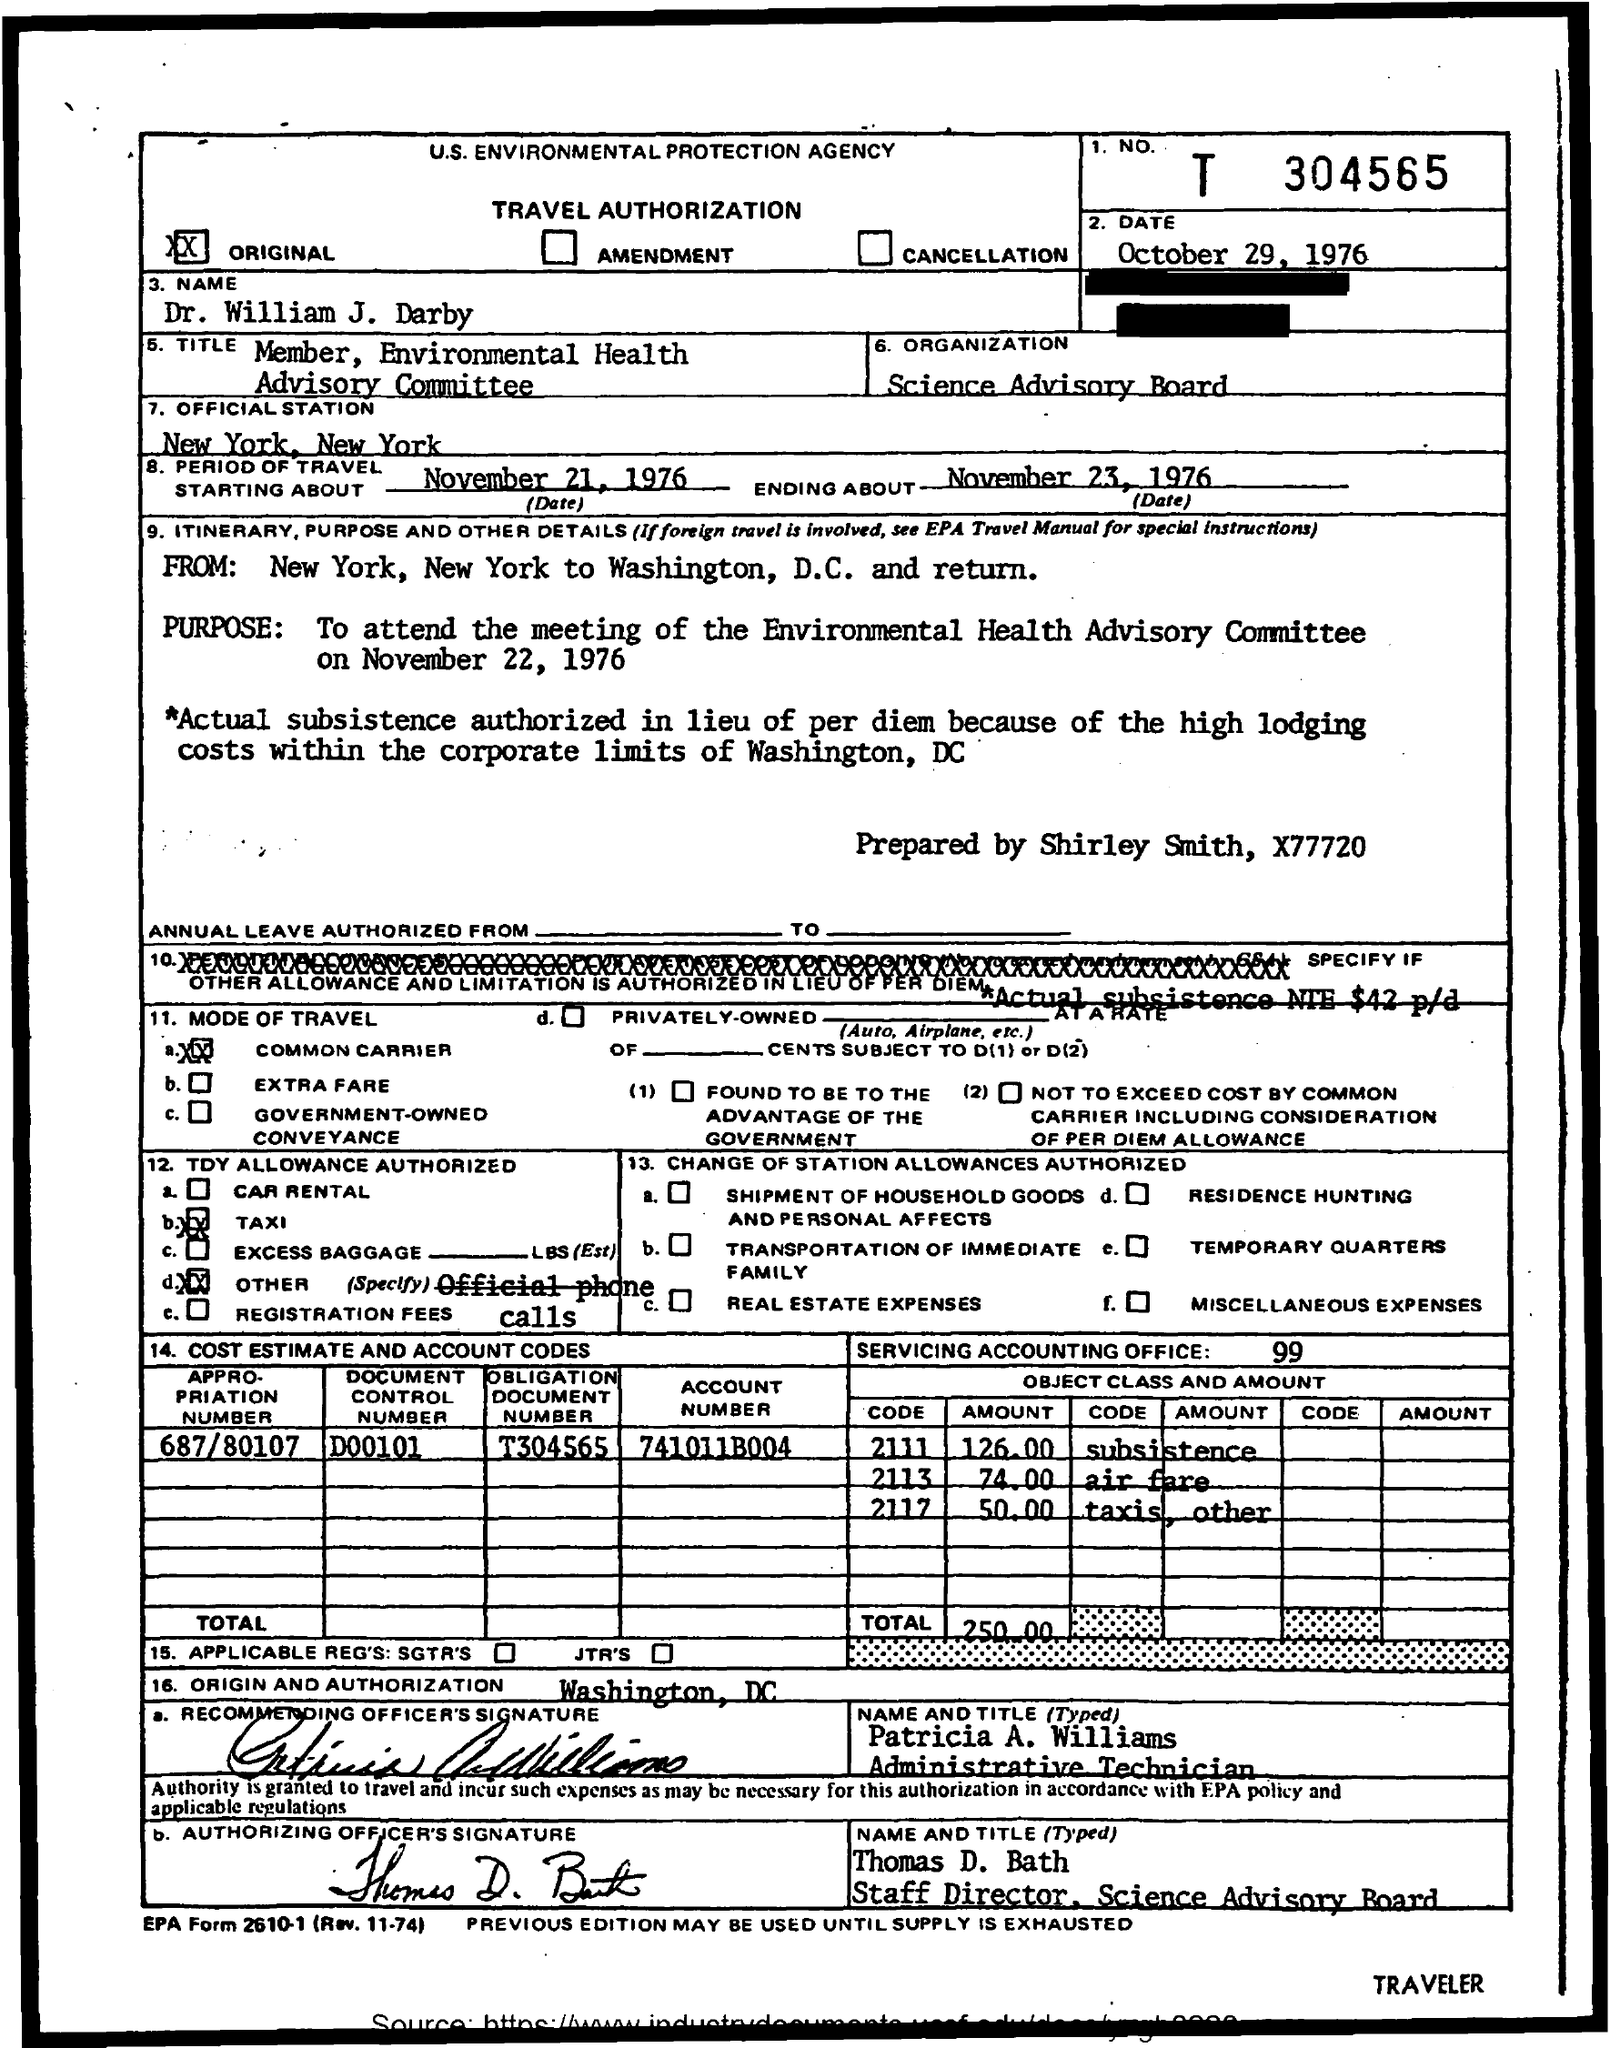What is the agency name?
Provide a short and direct response. U.S. Environmental protection agency. What type of document is it?
Offer a very short reply. Travel authorization. What is the period of travel start date?
Offer a very short reply. November 21, 1976. What is the period of travel end date?
Your answer should be very brief. November 23, 1976. What is the pupose of travel?
Offer a very short reply. To attend the meeting of the environmental health advisory committee. On which date is the meeting held?
Make the answer very short. November 22, 1976. By whom is it prepared by?
Provide a short and direct response. Shirley Smith. What is the mode of travel?
Give a very brief answer. Common carrier. What is the document control number?
Make the answer very short. D00101. What is the service accounting office number?
Offer a very short reply. 99. 